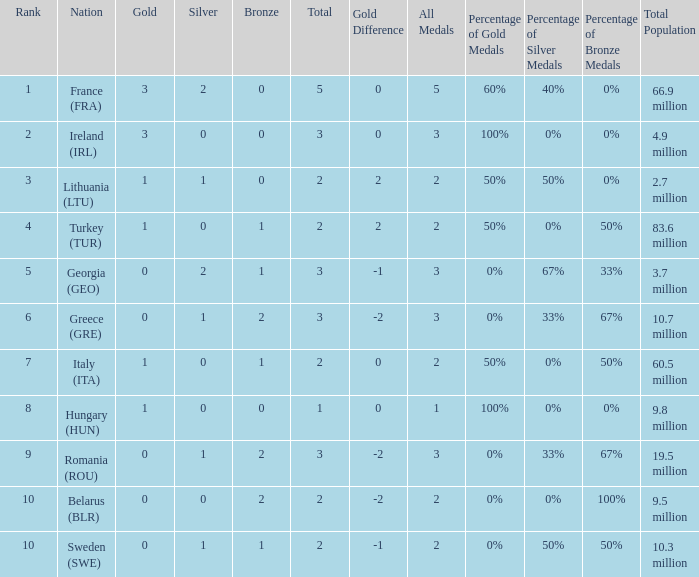What's the rank of Turkey (TUR) with a total more than 2? 0.0. 